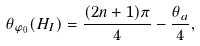<formula> <loc_0><loc_0><loc_500><loc_500>\theta _ { \varphi _ { 0 } } ( H _ { I } ) = \frac { ( 2 n + 1 ) \pi } { 4 } - \frac { \theta _ { a } } { 4 } ,</formula> 